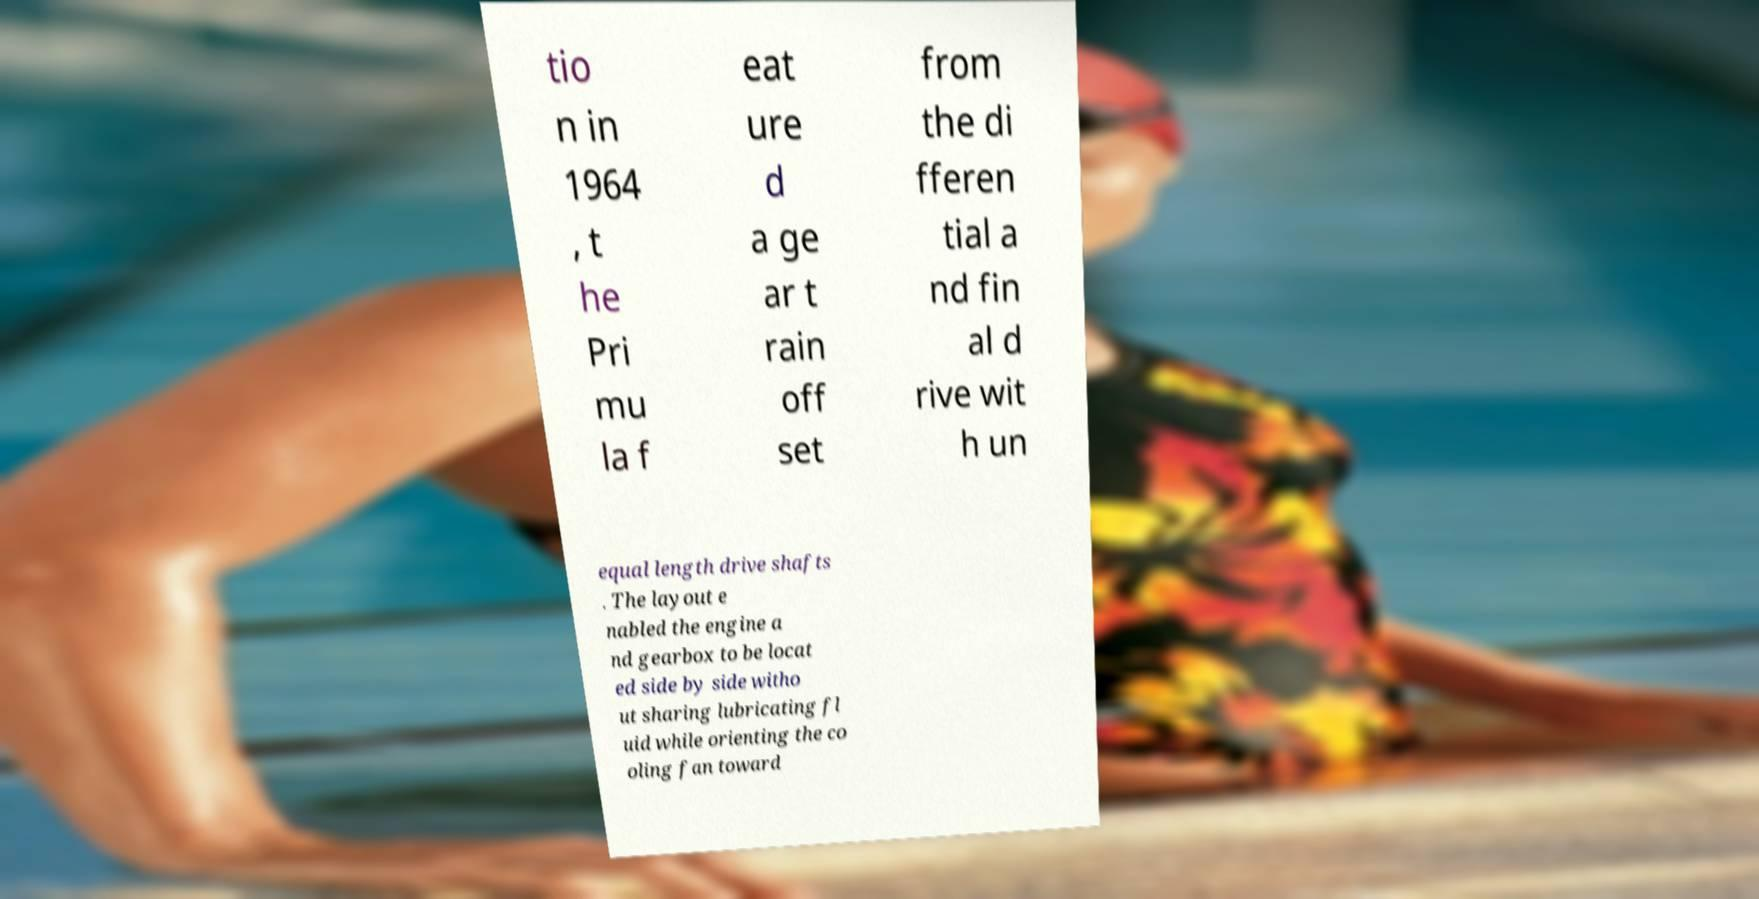Can you read and provide the text displayed in the image?This photo seems to have some interesting text. Can you extract and type it out for me? tio n in 1964 , t he Pri mu la f eat ure d a ge ar t rain off set from the di fferen tial a nd fin al d rive wit h un equal length drive shafts . The layout e nabled the engine a nd gearbox to be locat ed side by side witho ut sharing lubricating fl uid while orienting the co oling fan toward 